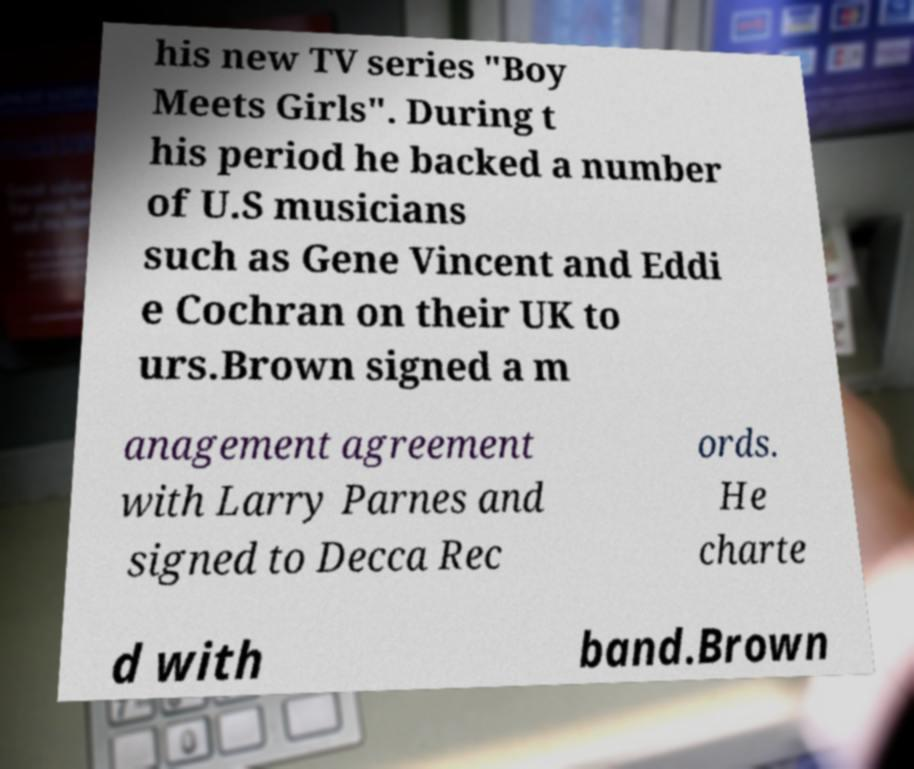Please read and relay the text visible in this image. What does it say? his new TV series "Boy Meets Girls". During t his period he backed a number of U.S musicians such as Gene Vincent and Eddi e Cochran on their UK to urs.Brown signed a m anagement agreement with Larry Parnes and signed to Decca Rec ords. He charte d with band.Brown 